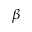<formula> <loc_0><loc_0><loc_500><loc_500>\beta</formula> 